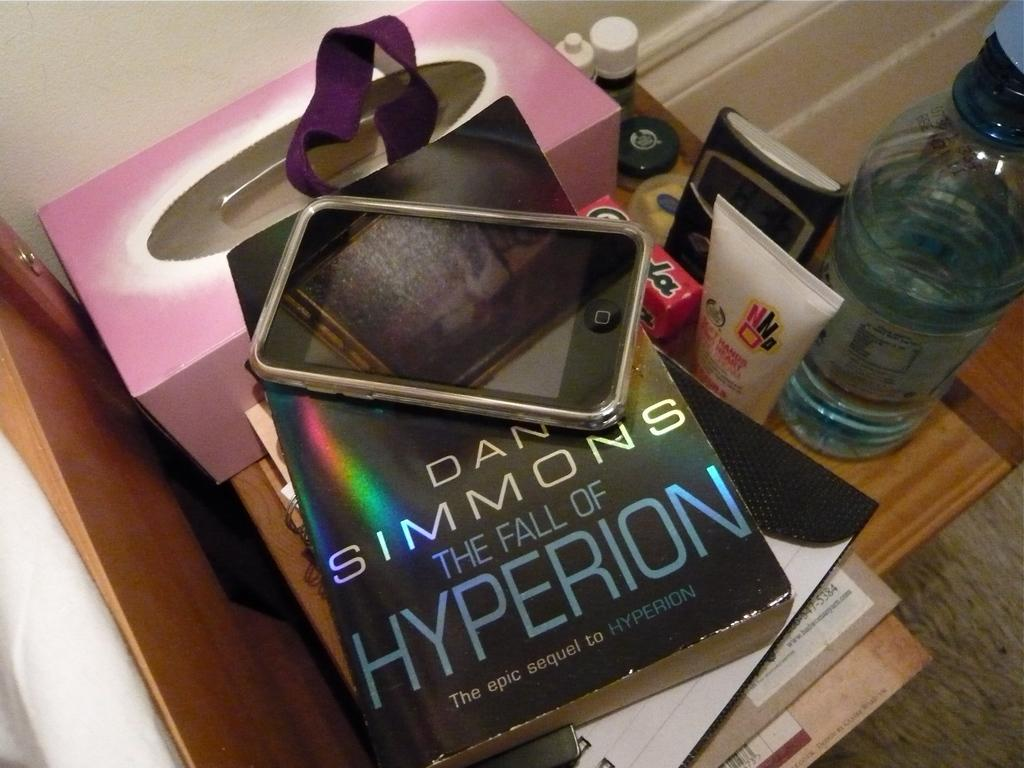<image>
Create a compact narrative representing the image presented. Book titled The Fall of Hyperion by Dan Simmons under a phone. 